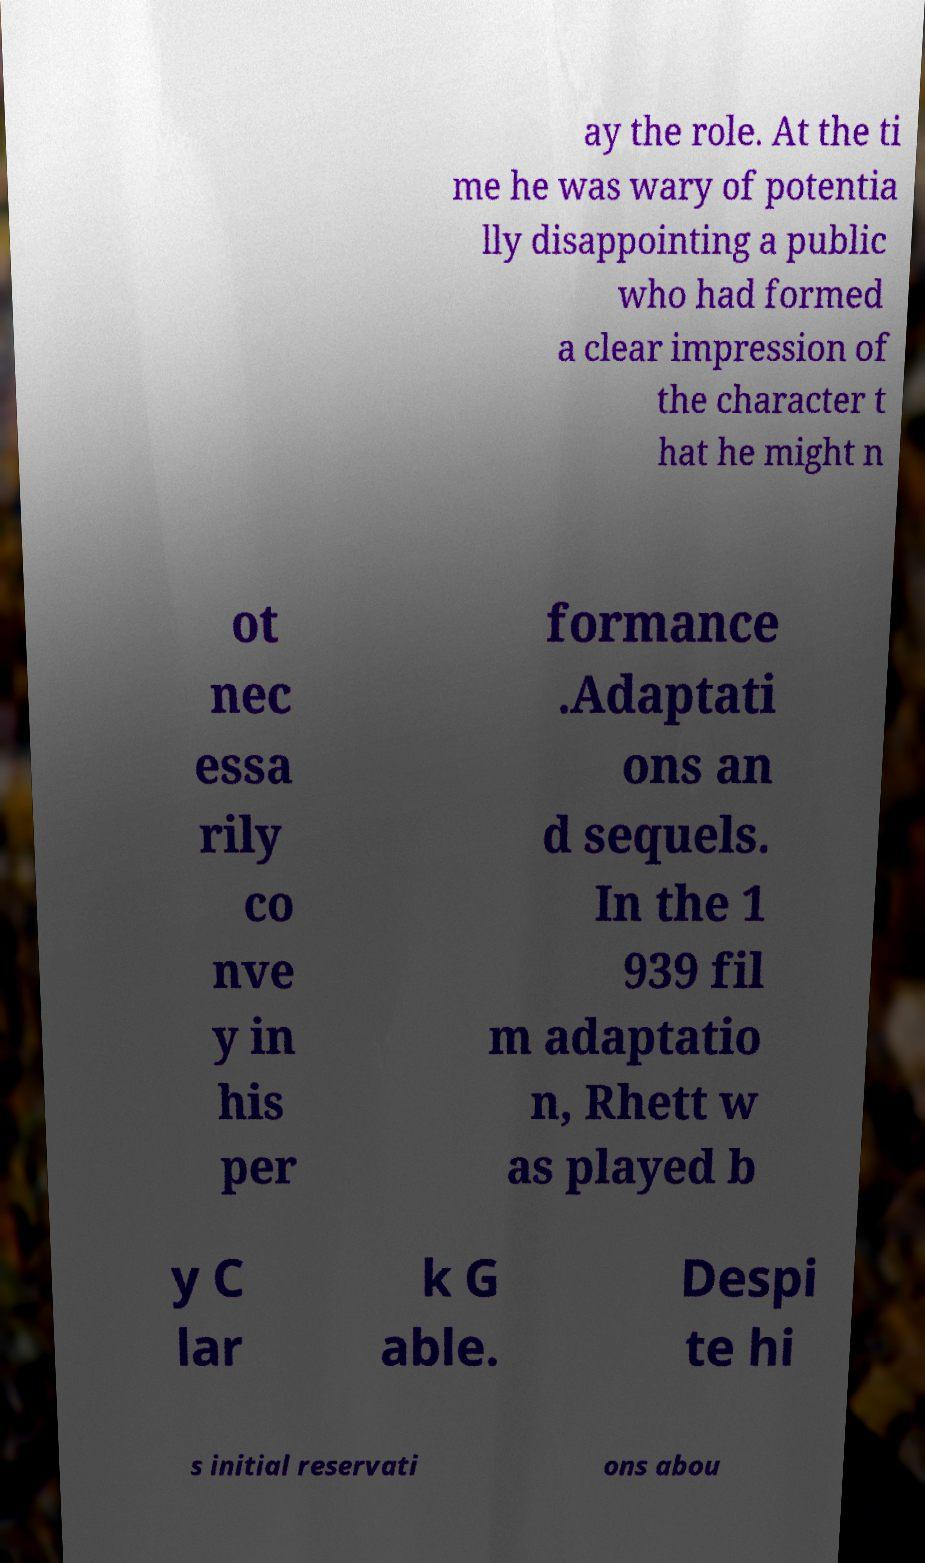Can you accurately transcribe the text from the provided image for me? ay the role. At the ti me he was wary of potentia lly disappointing a public who had formed a clear impression of the character t hat he might n ot nec essa rily co nve y in his per formance .Adaptati ons an d sequels. In the 1 939 fil m adaptatio n, Rhett w as played b y C lar k G able. Despi te hi s initial reservati ons abou 